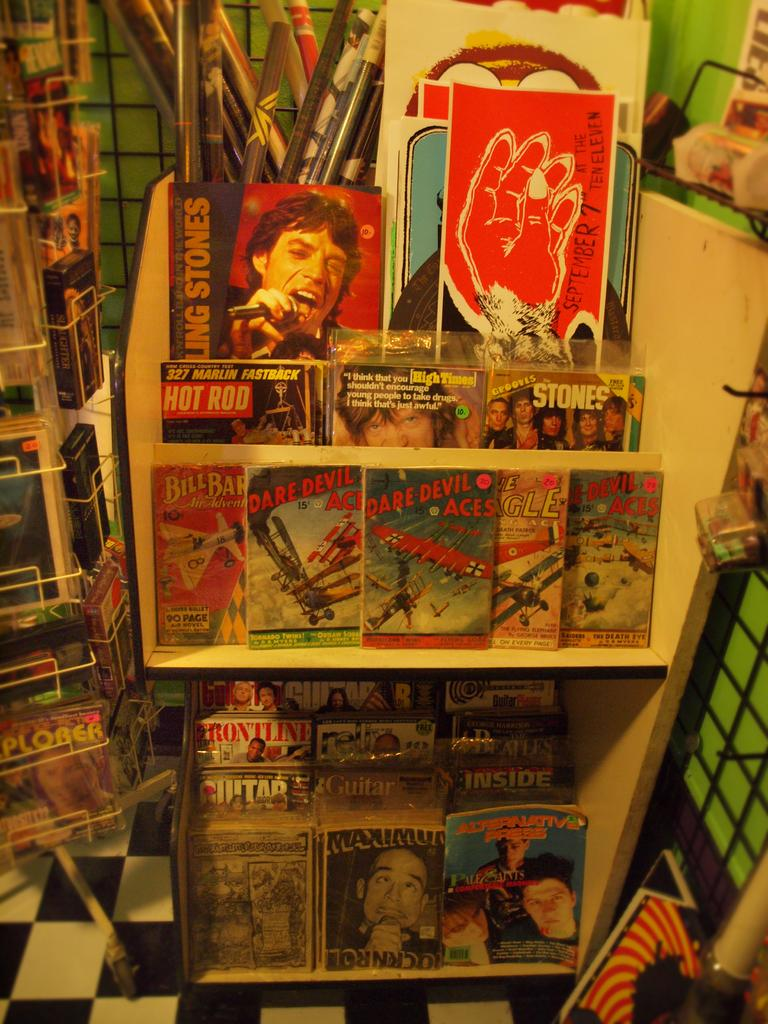<image>
Create a compact narrative representing the image presented. A bunch of books are on shelves and one is titled Hot Rod. 